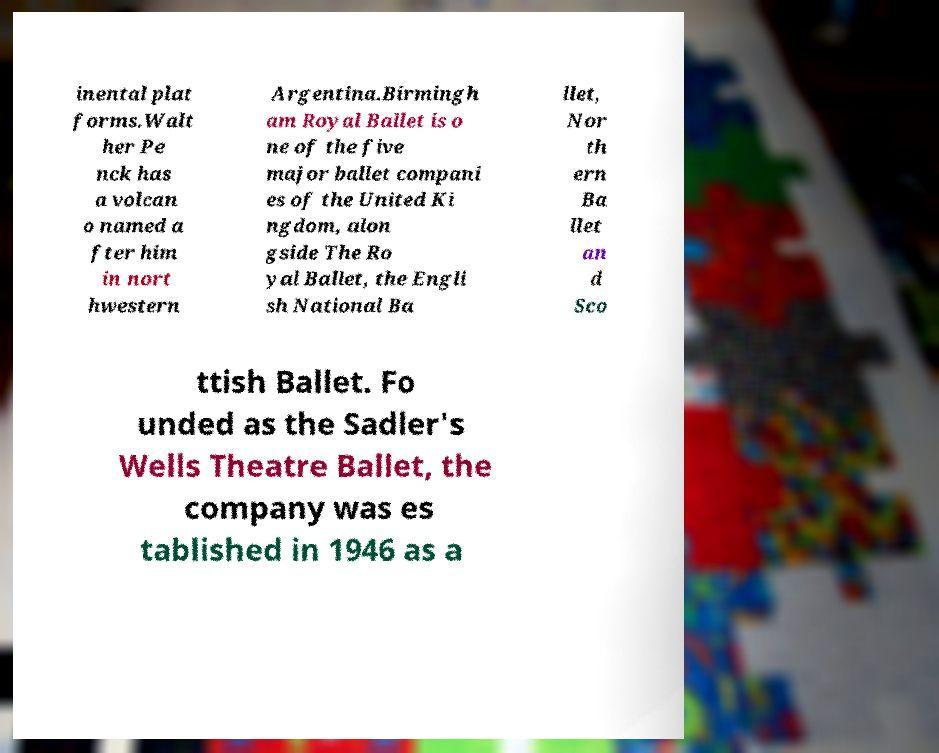Can you accurately transcribe the text from the provided image for me? inental plat forms.Walt her Pe nck has a volcan o named a fter him in nort hwestern Argentina.Birmingh am Royal Ballet is o ne of the five major ballet compani es of the United Ki ngdom, alon gside The Ro yal Ballet, the Engli sh National Ba llet, Nor th ern Ba llet an d Sco ttish Ballet. Fo unded as the Sadler's Wells Theatre Ballet, the company was es tablished in 1946 as a 